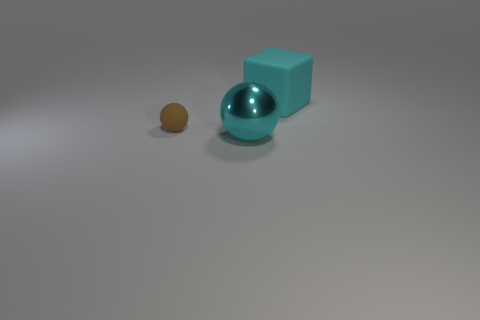Is there anything else that has the same material as the big cyan sphere?
Provide a short and direct response. No. Is there any other thing that has the same shape as the large cyan matte thing?
Make the answer very short. No. Is there a brown rubber sphere that has the same size as the brown thing?
Ensure brevity in your answer.  No. The big metallic sphere is what color?
Your response must be concise. Cyan. Do the matte sphere and the cyan shiny sphere have the same size?
Keep it short and to the point. No. How many objects are either big red balls or cyan things?
Provide a succinct answer. 2. Are there an equal number of large metallic balls in front of the big cyan matte block and big purple shiny cylinders?
Provide a succinct answer. No. There is a large cyan object in front of the cyan thing behind the small brown rubber object; is there a cyan matte cube on the left side of it?
Keep it short and to the point. No. There is a small sphere that is the same material as the cyan cube; what is its color?
Your response must be concise. Brown. Do the matte object to the left of the matte cube and the big matte block have the same color?
Your answer should be very brief. No. 